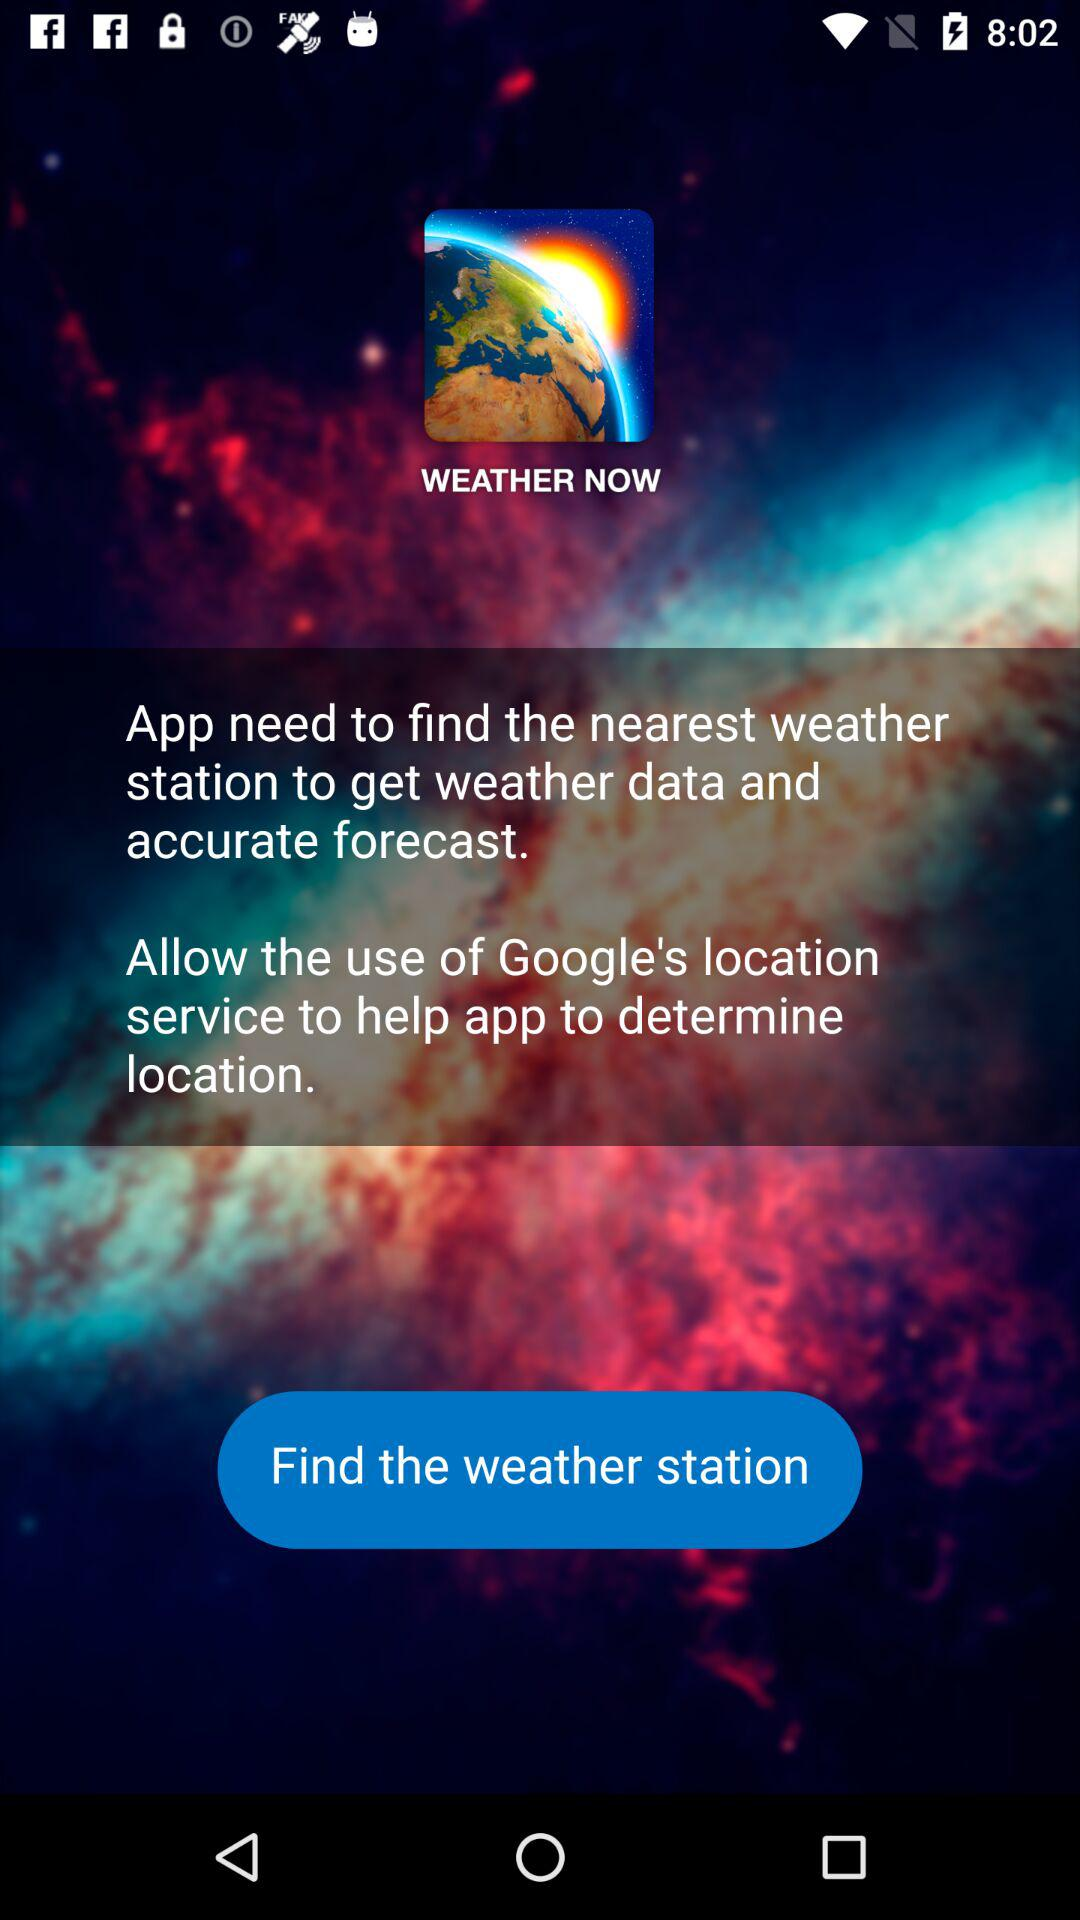What is the application name?
Answer the question using a single word or phrase. The application name is "WEATHER NOW" 